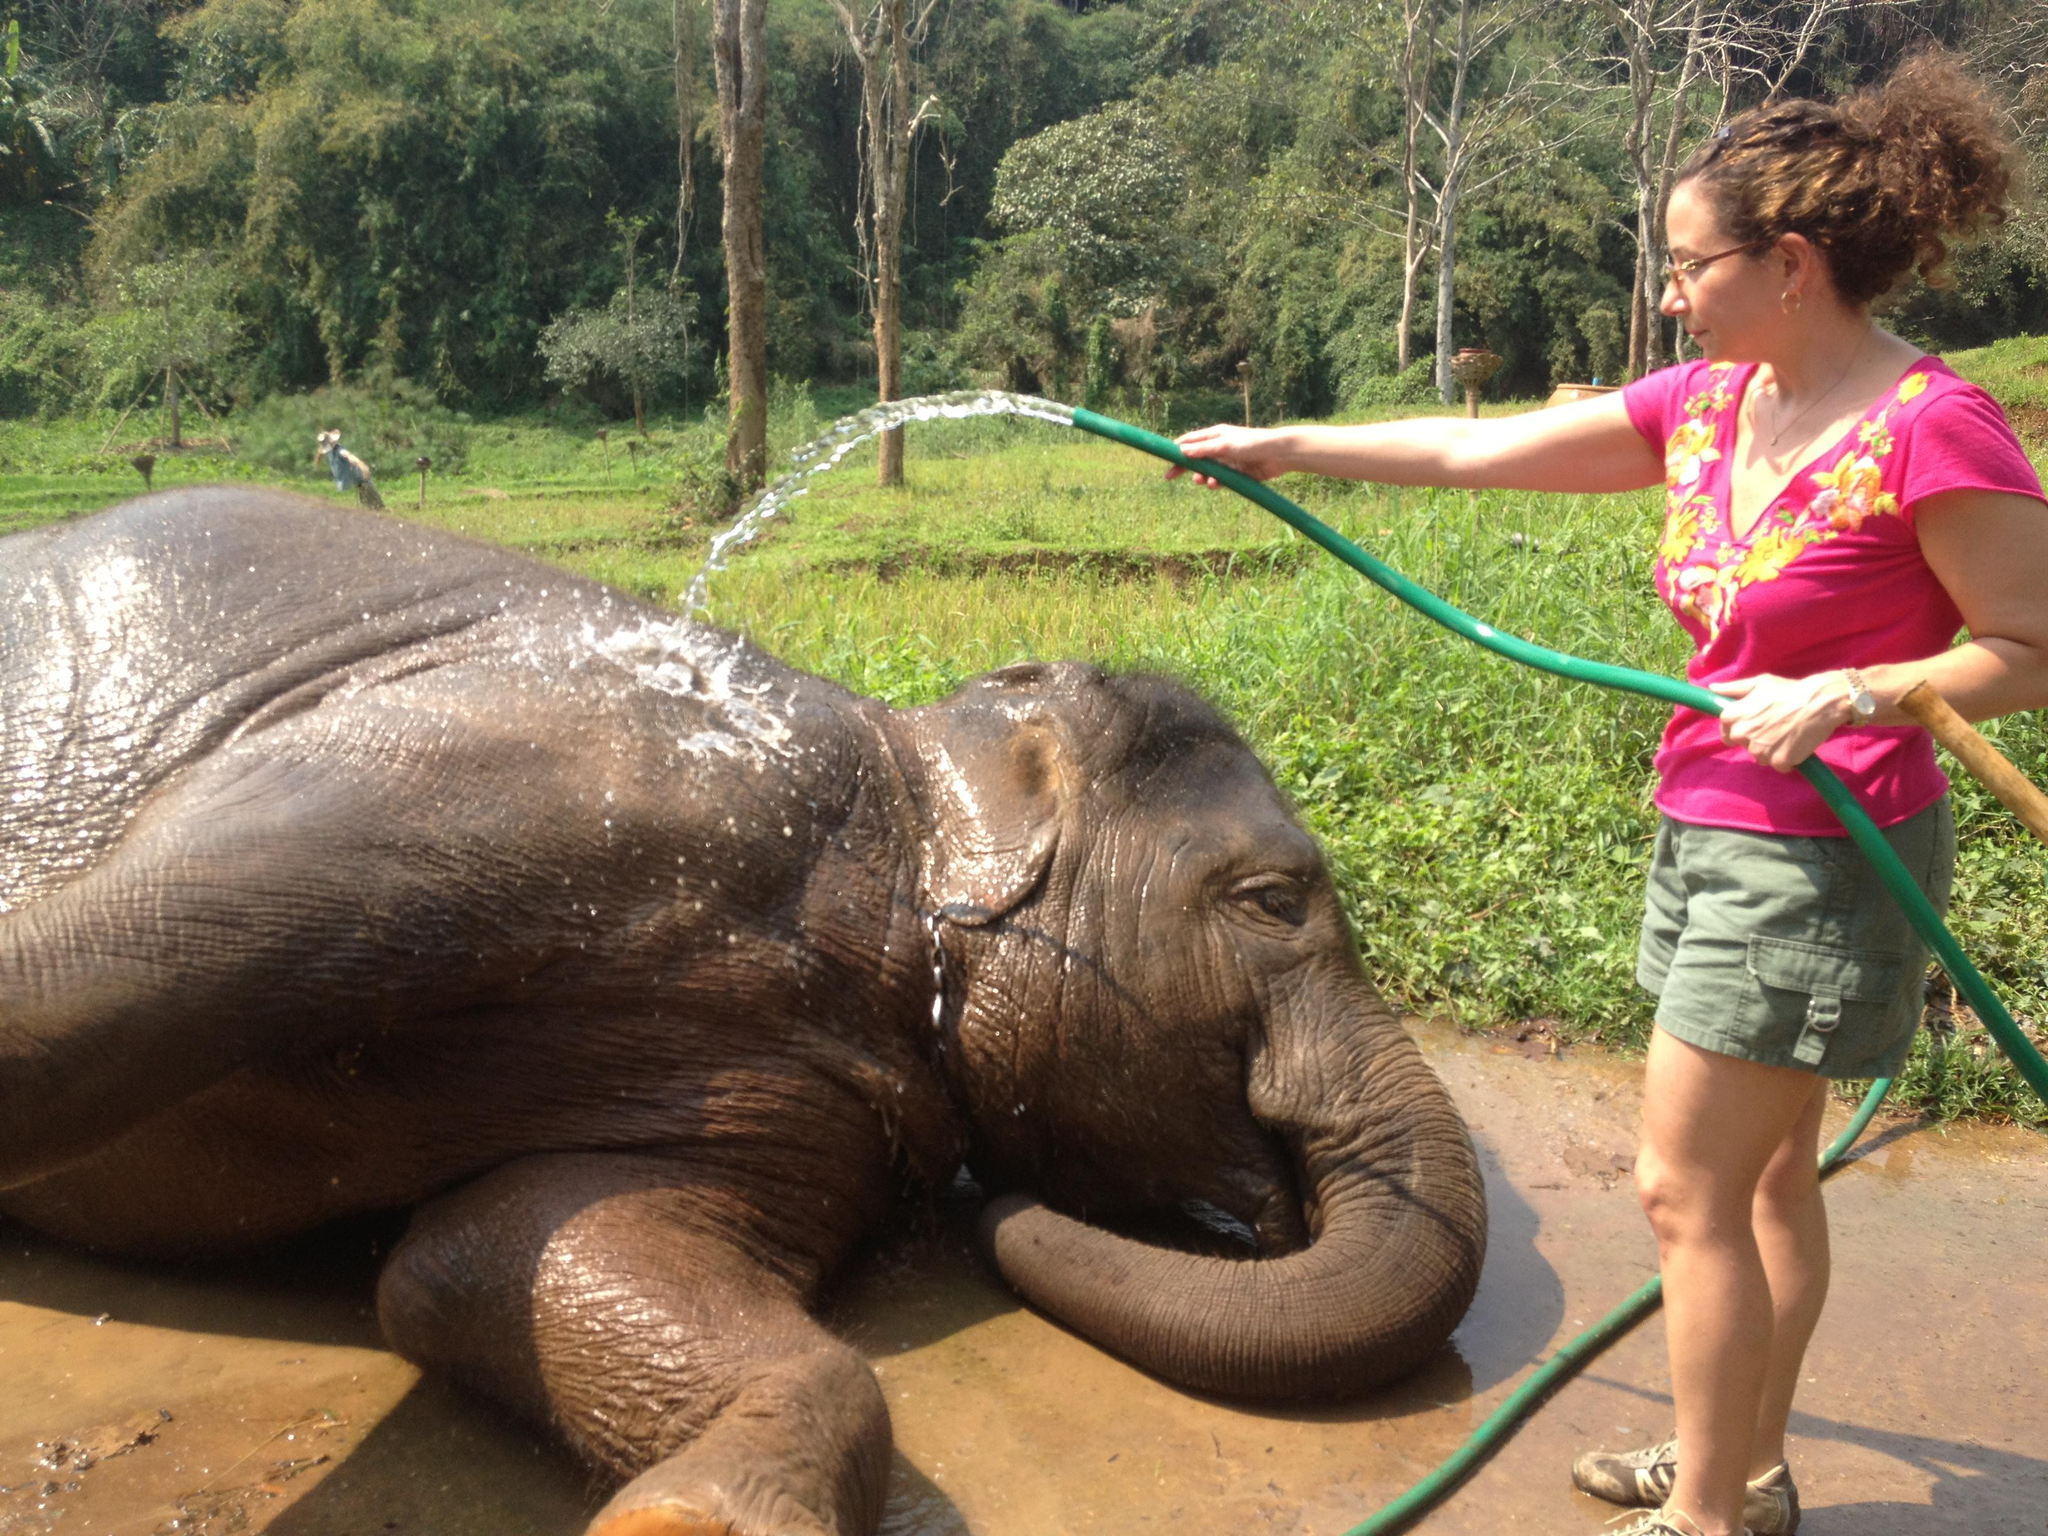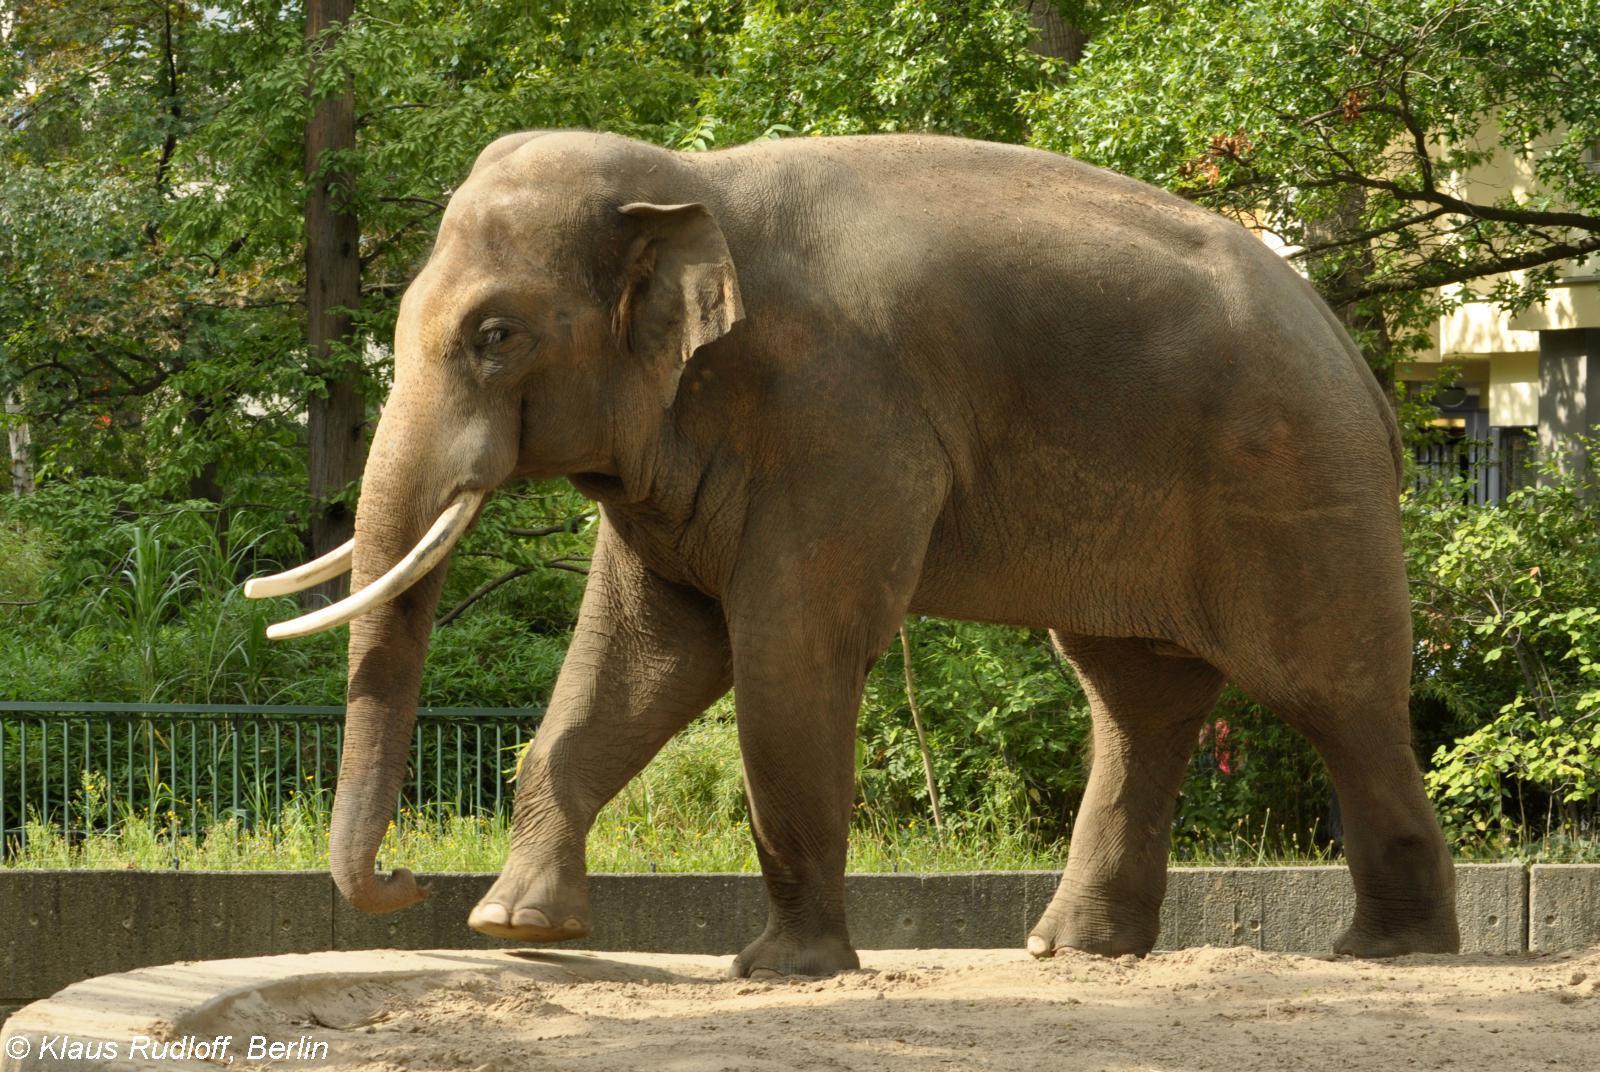The first image is the image on the left, the second image is the image on the right. Assess this claim about the two images: "the elephant on the right image is facing right.". Correct or not? Answer yes or no. No. 